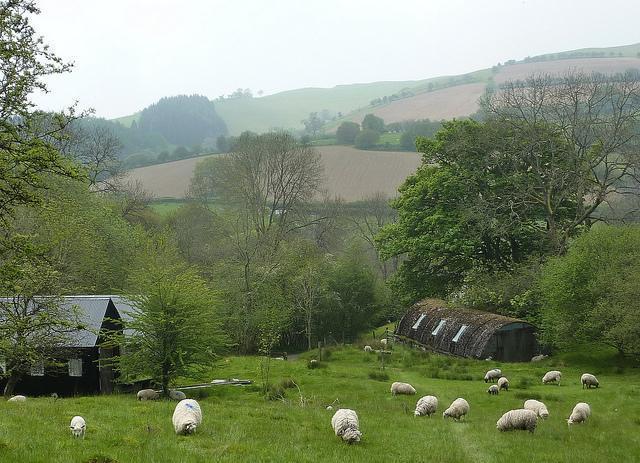What building material is the longhouse next to the sheep?
Choose the right answer and clarify with the format: 'Answer: answer
Rationale: rationale.'
Options: Mud, straw, sticks, brick. Answer: sticks.
Rationale: The longhouse is made out of a wooden material. 